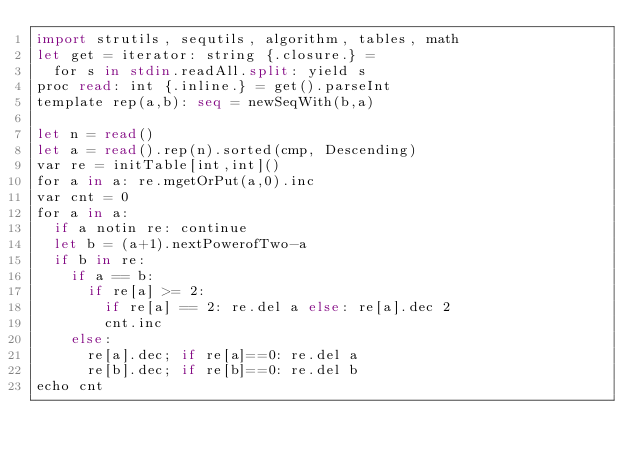<code> <loc_0><loc_0><loc_500><loc_500><_Haskell_>import strutils, sequtils, algorithm, tables, math
let get = iterator: string {.closure.} =
  for s in stdin.readAll.split: yield s
proc read: int {.inline.} = get().parseInt
template rep(a,b): seq = newSeqWith(b,a)

let n = read()
let a = read().rep(n).sorted(cmp, Descending)
var re = initTable[int,int]()
for a in a: re.mgetOrPut(a,0).inc
var cnt = 0
for a in a:
  if a notin re: continue
  let b = (a+1).nextPowerofTwo-a
  if b in re:
    if a == b:
      if re[a] >= 2:
        if re[a] == 2: re.del a else: re[a].dec 2
        cnt.inc
    else:
      re[a].dec; if re[a]==0: re.del a
      re[b].dec; if re[b]==0: re.del b
echo cnt
</code> 